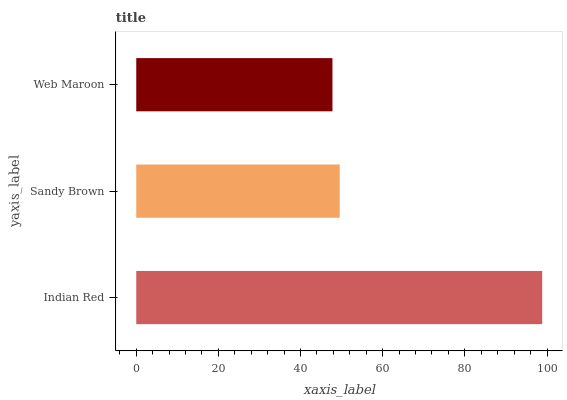Is Web Maroon the minimum?
Answer yes or no. Yes. Is Indian Red the maximum?
Answer yes or no. Yes. Is Sandy Brown the minimum?
Answer yes or no. No. Is Sandy Brown the maximum?
Answer yes or no. No. Is Indian Red greater than Sandy Brown?
Answer yes or no. Yes. Is Sandy Brown less than Indian Red?
Answer yes or no. Yes. Is Sandy Brown greater than Indian Red?
Answer yes or no. No. Is Indian Red less than Sandy Brown?
Answer yes or no. No. Is Sandy Brown the high median?
Answer yes or no. Yes. Is Sandy Brown the low median?
Answer yes or no. Yes. Is Web Maroon the high median?
Answer yes or no. No. Is Web Maroon the low median?
Answer yes or no. No. 